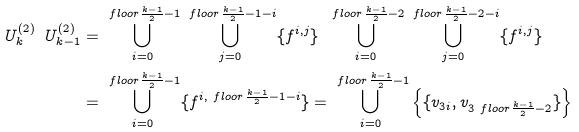Convert formula to latex. <formula><loc_0><loc_0><loc_500><loc_500>U _ { k } ^ { ( 2 ) } \ U _ { k - 1 } ^ { ( 2 ) } & = \bigcup _ { i = 0 } ^ { \ f l o o r { \frac { k - 1 } { 2 } } - 1 } \bigcup _ { j = 0 } ^ { \ f l o o r { \frac { k - 1 } { 2 } } - 1 - i } \{ f ^ { i , j } \} \ \bigcup _ { i = 0 } ^ { \ f l o o r { \frac { k - 1 } { 2 } } - 2 } \bigcup _ { j = 0 } ^ { \ f l o o r { \frac { k - 1 } { 2 } } - 2 - i } \{ f ^ { i , j } \} \\ & = \bigcup _ { i = 0 } ^ { \ f l o o r { \frac { k - 1 } { 2 } } - 1 } \{ f ^ { i , \ f l o o r { \frac { k - 1 } { 2 } } - 1 - i } \} = \bigcup _ { i = 0 } ^ { \ f l o o r { \frac { k - 1 } { 2 } } - 1 } \left \{ \{ v _ { 3 i } , v _ { 3 \ f l o o r { \frac { k - 1 } { 2 } } - 2 } \} \right \}</formula> 